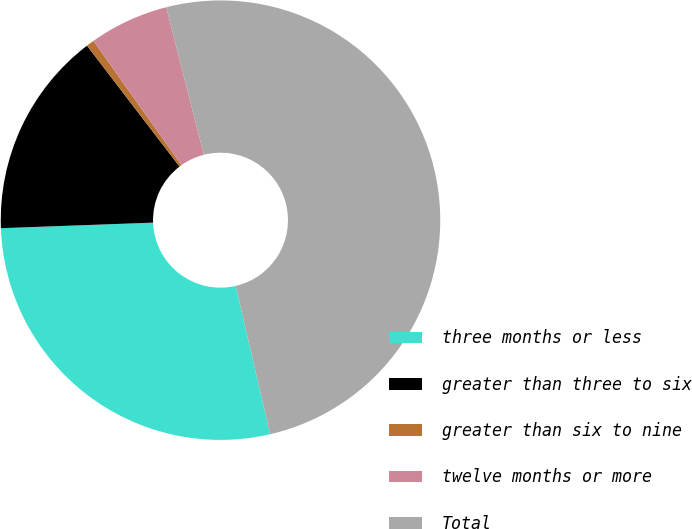Convert chart. <chart><loc_0><loc_0><loc_500><loc_500><pie_chart><fcel>three months or less<fcel>greater than three to six<fcel>greater than six to nine<fcel>twelve months or more<fcel>Total<nl><fcel>28.04%<fcel>15.19%<fcel>0.58%<fcel>5.84%<fcel>50.35%<nl></chart> 